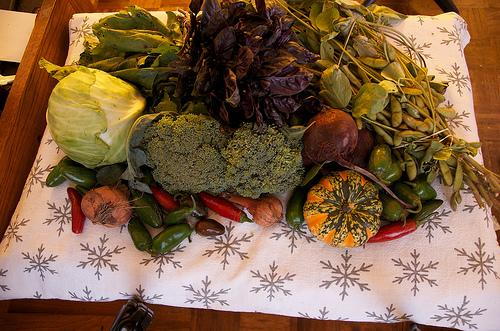Could the image be used to promote healthy eating? Explain your answer. Yes, the image can be used to promote healthy eating, as it prominently showcases a variety of vibrant fresh vegetables, which are essential for a healthy diet. Which vegetables are partially hidden or not fully visible in the image? Part of red pepper, part of green pepper, part of yellow squash, and a beetroot behind the squash are partially hidden or not fully visible in the image. Describe the color schemes present in the image. The color scheme includes a mix of green, red, yellow, orange, purple, and neutral colors like the wood, cloth, and snowflakes. Describe the overall sentiment of the image. The image has a fresh, healthy, and vibrant sentiment, focusing on a diverse and colorful selection of vegetables. Which vegetable appears to be wilting or dirty? The head of lettuce appears to be dirty. Mention the background features in this photo. The background features a wooden surface and a cloth with snowflake patterns covering the table upon which the vegetables are laid. How many distinct snowflake designs can be seen on the cloth? There are four distinct snowflake designs, one large and three smaller designs, on the cloth. What is the primary focus of the image? A pile of vegetables including cabbage, brussel sprouts, peppers, squash, lettuce, broccoli, and other colorful produce on a table with a snowflake-patterned cloth. Identify a two-word description for the main objects found in the image. Healthy vegetables. Count the distinctive types of vegetables depicted in this image. There are at least 12 different types of vegetables, such as cabbage, brussel sprouts, peppers, squash, broccoli, lettuce, beets, gourds, jalapeno peppers, basil, and leafy greens. Select the description that best depicts the background in the image. Options: A) Wood behind the towel, B) Grassy plain behind the towel, C) Brick wall behind the towel. A) Wood behind the towel Identify the vegetable with a leafy purple appearance. Leafy purple vegetable Which vegetable has a green top and a red body in the image? Red pepper with green top How many green peppers are highlighted in four green peppers together? Four Provide a brief description for the set of vegetables in the image. Nice variety of healthy vegetables on a towel with snowflake pattern What is the dominant object found in the "delicious set of healthy vegetables"? Pile of many different vegetables What color is the gourd with a green top? Orange What type of pattern is found on the cloth in the image? Snowflake What can be found on the tablecloth among the vegetables? Snowflake pattern What type of greens can be seen among the vegetables? Dark leafy greens Point out the object described as "a squash on the towel." Yellow and green squash on the bottom right corner How are the two bunches of broccoli positioned in the image with respect to other vegetables? Near each other, between the heads of brussel sprouts and green peppers Describe the placement and appearance of the chili peppers. Green and red chili pepper on the towel near the orange gourd Which vegetables are interacting with each other in the pile? Several, including beetroot, broccoli, squash, green pepper, and red pepper Which type of lettuce appears to be closest to the tablecloth? Light green head of iceberg lettuce Due to unsanitary conditions, which food item should not be consumed? Dirty head of lettuce What vegetable does the caption "beet in a pile of vegetables" refer to? Beetroot Which of these options is the most accurate description of the squash? Options: A) Only yellow squash, B) Only green squash, C) Yellow and green squash. C) Yellow and green squash What is the main color of the cabbage in the image? Green 